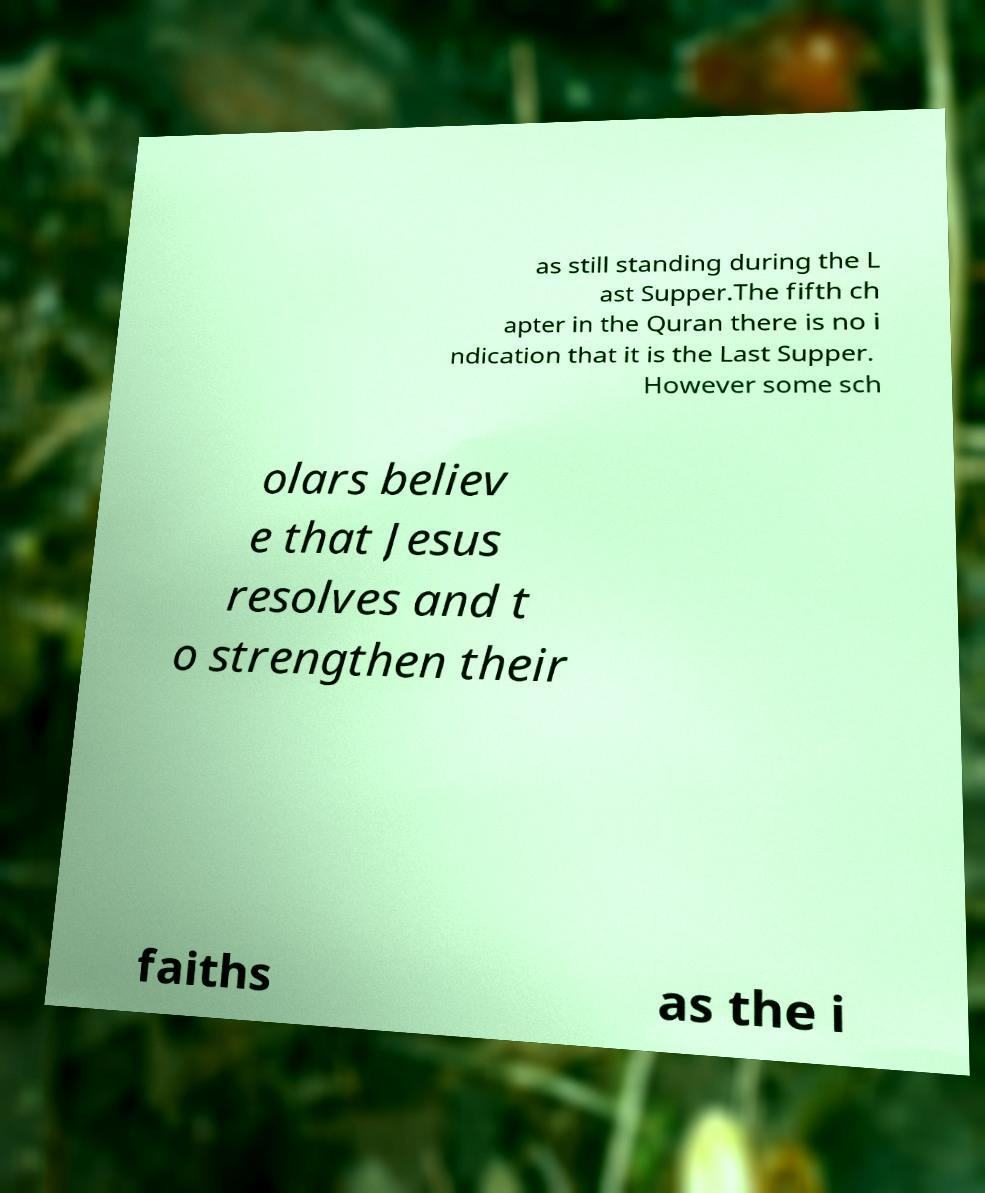I need the written content from this picture converted into text. Can you do that? as still standing during the L ast Supper.The fifth ch apter in the Quran there is no i ndication that it is the Last Supper. However some sch olars believ e that Jesus resolves and t o strengthen their faiths as the i 